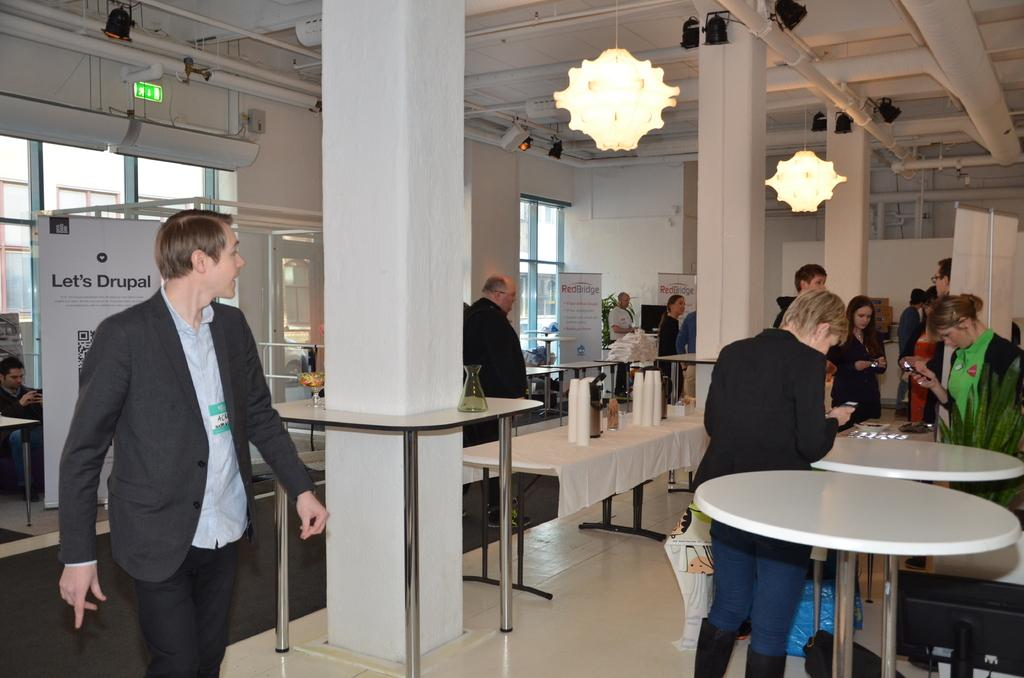How many people are in the image? The number of people in the image cannot be determined from the provided facts. What are the people doing in the image? The people are standing around a table in the image. What can be seen on the ceiling in the image? There are lights on the ceiling in the image. What type of location might the image depict? The setting appears to be a breakout hall. What is the price of the sidewalk in the image? There is no sidewalk present in the image, so it is not possible to determine its price. 